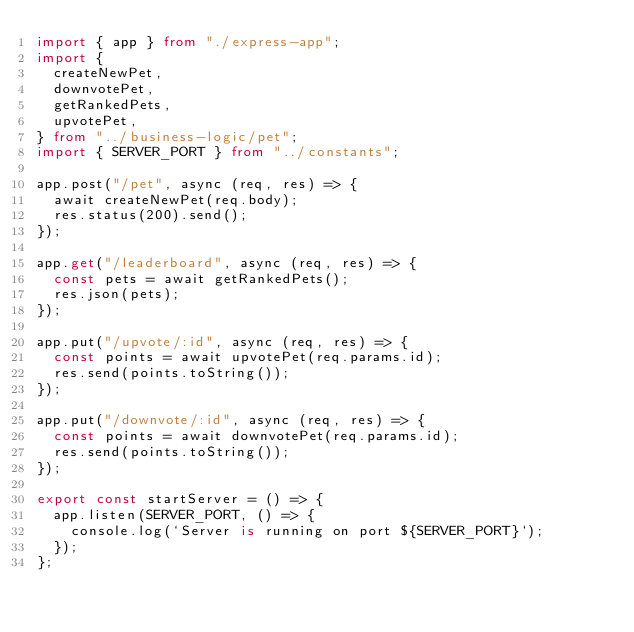<code> <loc_0><loc_0><loc_500><loc_500><_TypeScript_>import { app } from "./express-app";
import {
  createNewPet,
  downvotePet,
  getRankedPets,
  upvotePet,
} from "../business-logic/pet";
import { SERVER_PORT } from "../constants";

app.post("/pet", async (req, res) => {
  await createNewPet(req.body);
  res.status(200).send();
});

app.get("/leaderboard", async (req, res) => {
  const pets = await getRankedPets();
  res.json(pets);
});

app.put("/upvote/:id", async (req, res) => {
  const points = await upvotePet(req.params.id);
  res.send(points.toString());
});

app.put("/downvote/:id", async (req, res) => {
  const points = await downvotePet(req.params.id);
  res.send(points.toString());
});

export const startServer = () => {
  app.listen(SERVER_PORT, () => {
    console.log(`Server is running on port ${SERVER_PORT}`);
  });
};
</code> 